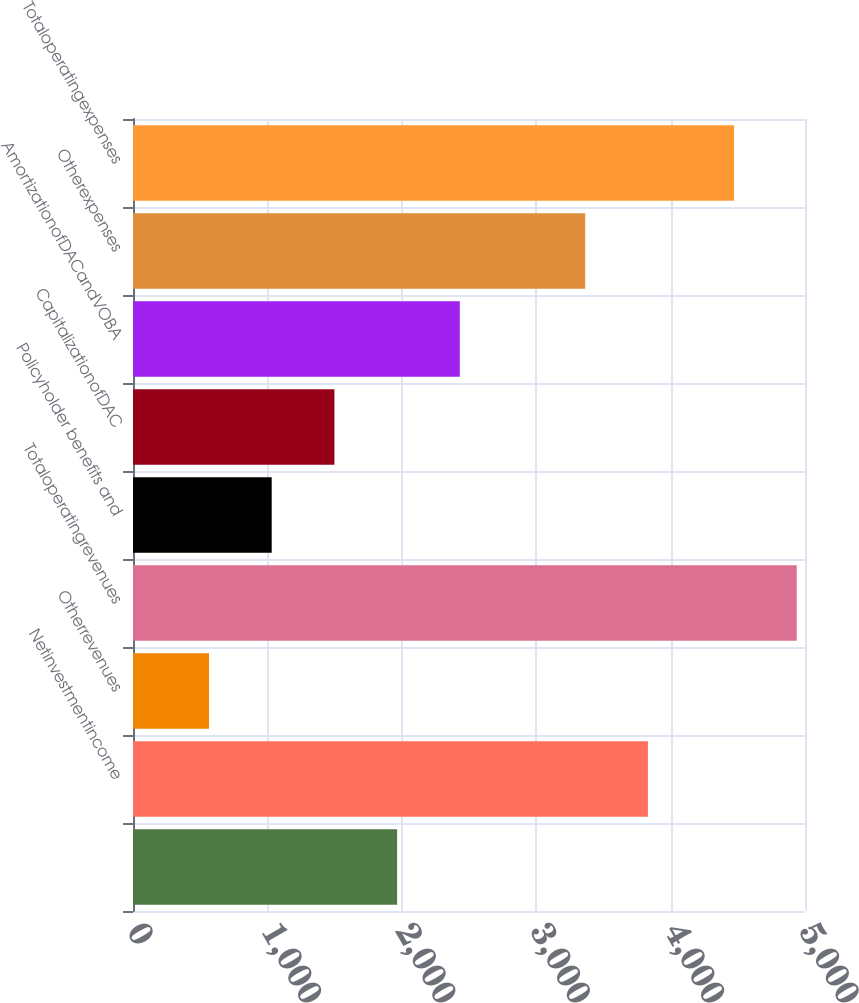Convert chart to OTSL. <chart><loc_0><loc_0><loc_500><loc_500><bar_chart><ecel><fcel>Netinvestmentincome<fcel>Otherrevenues<fcel>Totaloperatingrevenues<fcel>Policyholder benefits and<fcel>CapitalizationofDAC<fcel>AmortizationofDACandVOBA<fcel>Otherexpenses<fcel>Totaloperatingexpenses<nl><fcel>1965<fcel>3831<fcel>565.5<fcel>4938.5<fcel>1032<fcel>1498.5<fcel>2431.5<fcel>3364.5<fcel>4472<nl></chart> 